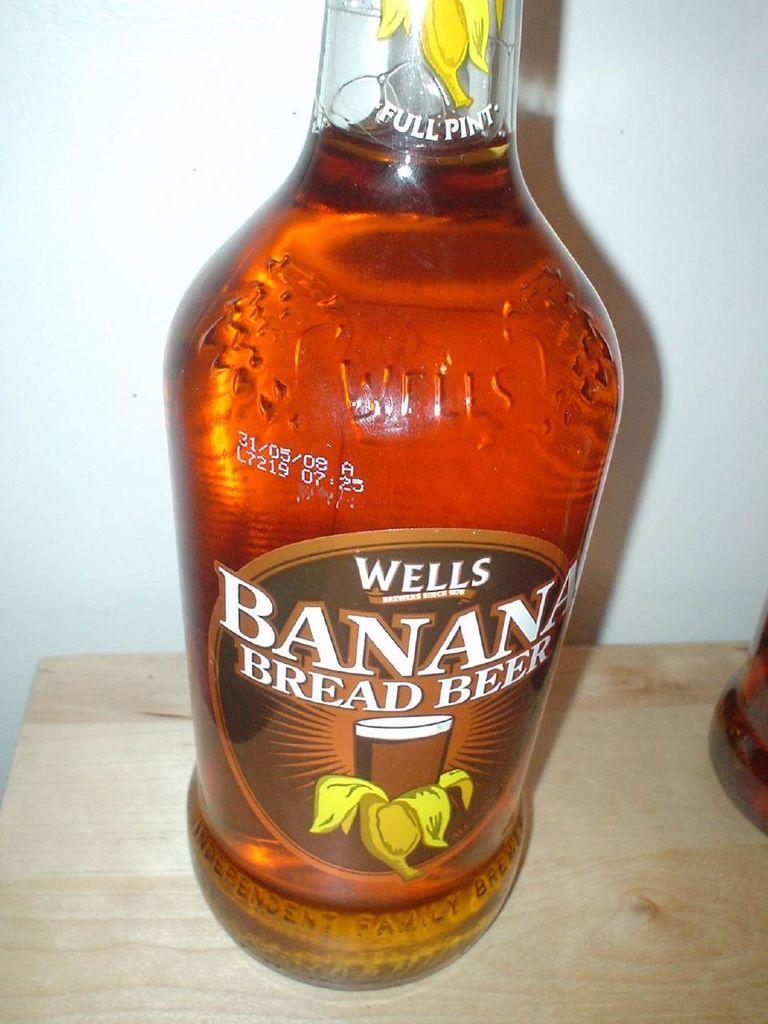<image>
Summarize the visual content of the image. a close up of Wells Banana Bread Beer Full Pint 